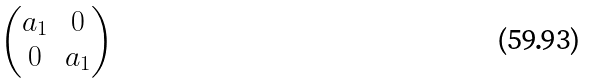Convert formula to latex. <formula><loc_0><loc_0><loc_500><loc_500>\begin{pmatrix} a _ { 1 } & 0 \\ 0 & a _ { 1 } \end{pmatrix}</formula> 